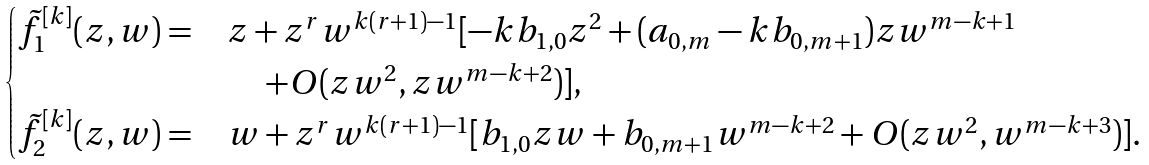<formula> <loc_0><loc_0><loc_500><loc_500>\begin{cases} \tilde { f } ^ { [ k ] } _ { 1 } ( z , w ) = & z + z ^ { r } w ^ { k ( r + 1 ) - 1 } [ - k b _ { 1 , 0 } z ^ { 2 } + ( a _ { 0 , m } - k b _ { 0 , m + 1 } ) z w ^ { m - k + 1 } \\ & \quad \, + O ( z w ^ { 2 } , z w ^ { m - k + 2 } ) ] , \\ \tilde { f } ^ { [ k ] } _ { 2 } ( z , w ) = & w + z ^ { r } w ^ { k ( r + 1 ) - 1 } [ b _ { 1 , 0 } z w + b _ { 0 , m + 1 } w ^ { m - k + 2 } + O ( z w ^ { 2 } , w ^ { m - k + 3 } ) ] . \end{cases}</formula> 